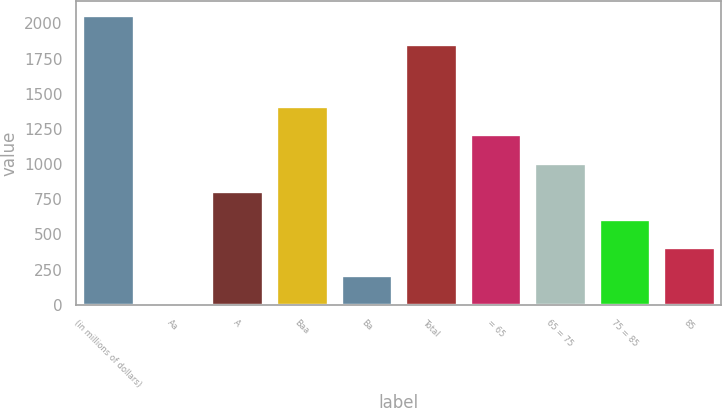<chart> <loc_0><loc_0><loc_500><loc_500><bar_chart><fcel>(in millions of dollars)<fcel>Aa<fcel>A<fcel>Baa<fcel>Ba<fcel>Total<fcel>= 65<fcel>65 = 75<fcel>75 = 85<fcel>85<nl><fcel>2057.23<fcel>7.7<fcel>810.22<fcel>1412.11<fcel>208.33<fcel>1856.6<fcel>1211.48<fcel>1010.85<fcel>609.59<fcel>408.96<nl></chart> 